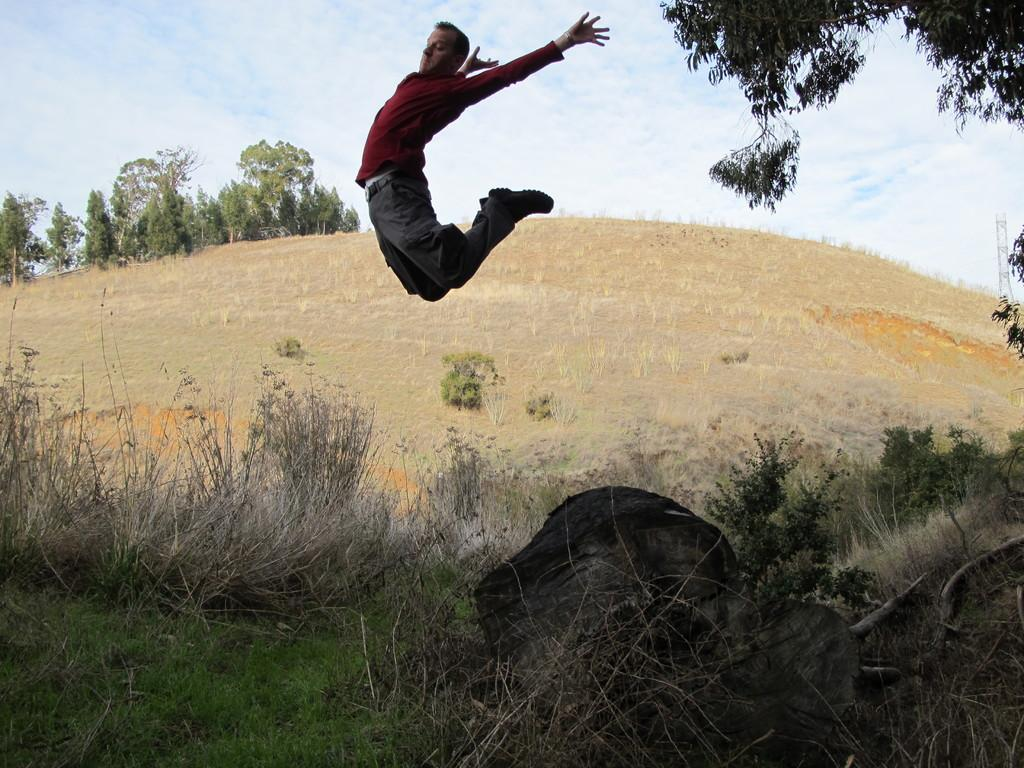Who is the main subject in the image? There is a man in the image. What is the man doing in the image? The man is jumping from the ground. What type of terrain is visible in the image? There is a lot of grass on the ground. What can be seen in the background of the image? There are trees in the background of the image. What word is the man trying to spell with his jump in the image? There is no indication in the image that the man is trying to spell a word with his jump. 